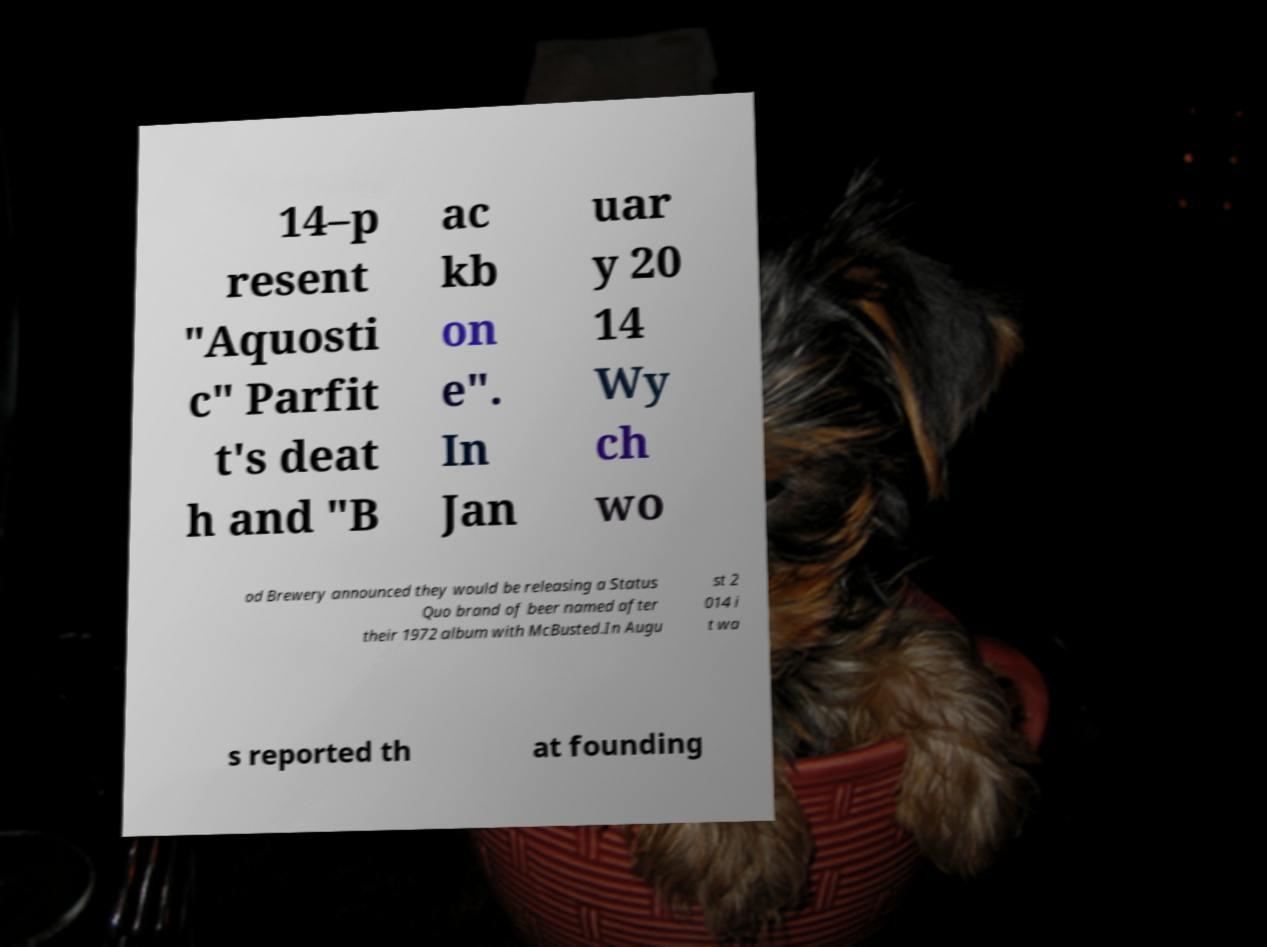Could you extract and type out the text from this image? 14–p resent "Aquosti c" Parfit t's deat h and "B ac kb on e". In Jan uar y 20 14 Wy ch wo od Brewery announced they would be releasing a Status Quo brand of beer named after their 1972 album with McBusted.In Augu st 2 014 i t wa s reported th at founding 